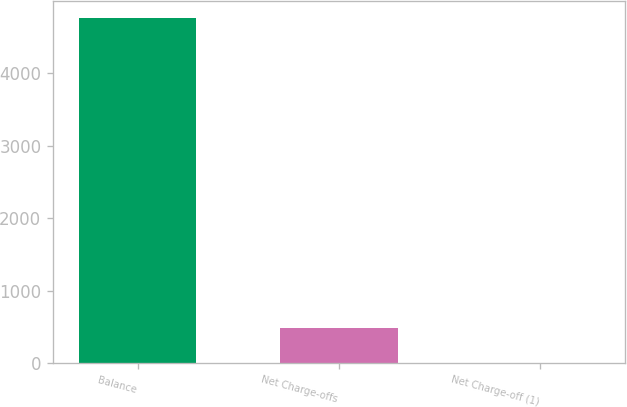<chart> <loc_0><loc_0><loc_500><loc_500><bar_chart><fcel>Balance<fcel>Net Charge-offs<fcel>Net Charge-off (1)<nl><fcel>4759<fcel>479.9<fcel>4.44<nl></chart> 